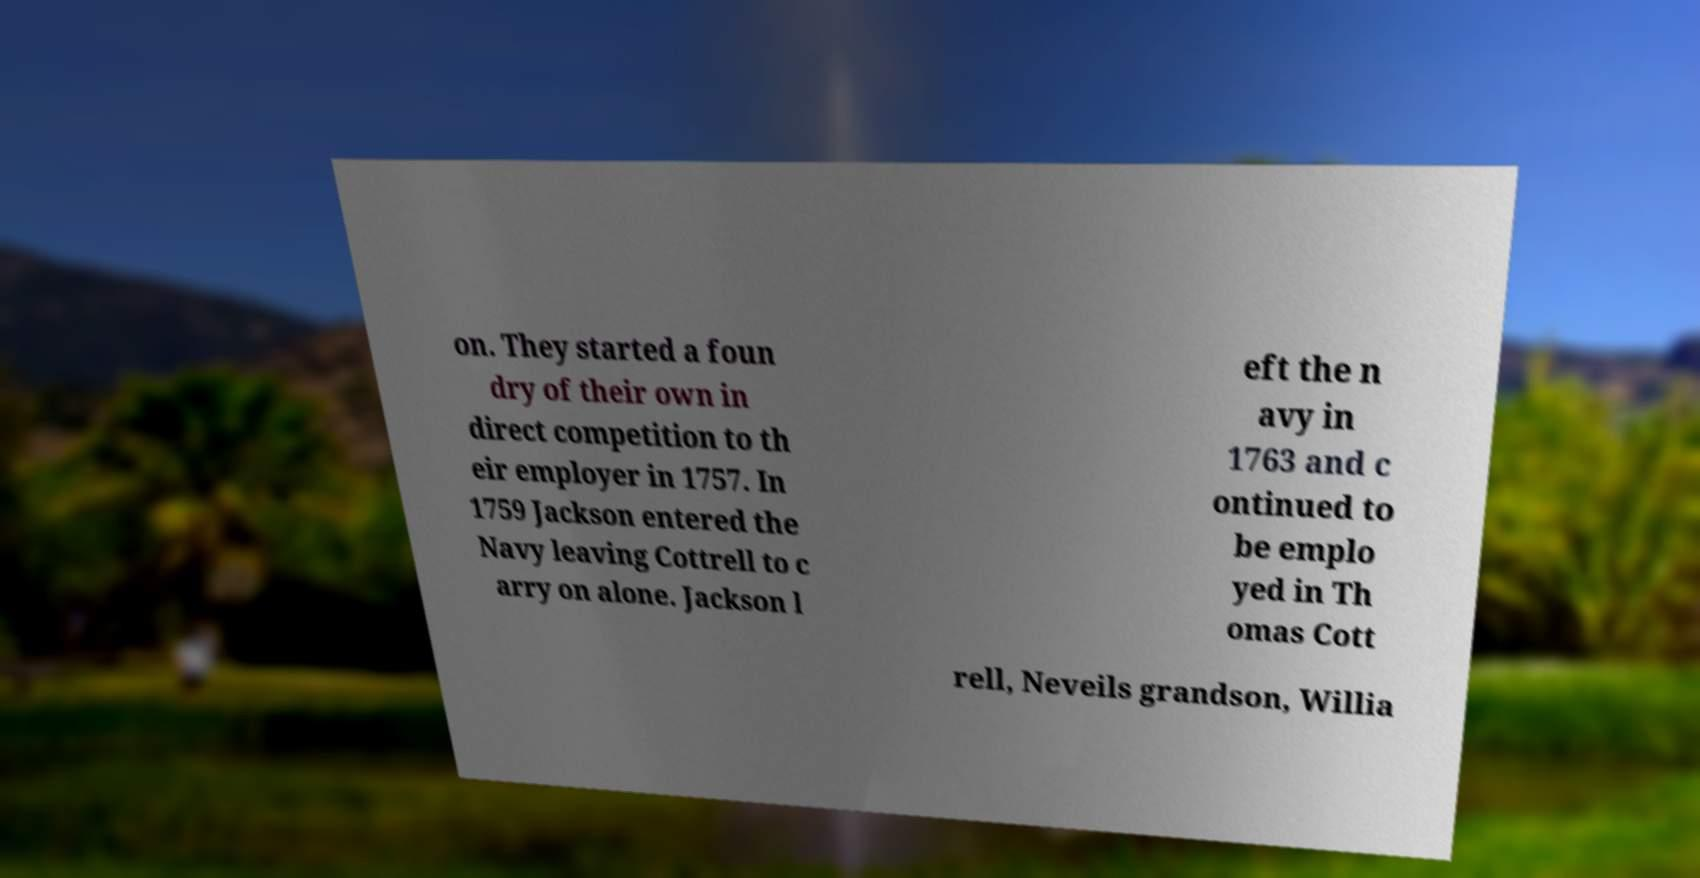For documentation purposes, I need the text within this image transcribed. Could you provide that? on. They started a foun dry of their own in direct competition to th eir employer in 1757. In 1759 Jackson entered the Navy leaving Cottrell to c arry on alone. Jackson l eft the n avy in 1763 and c ontinued to be emplo yed in Th omas Cott rell, Neveils grandson, Willia 